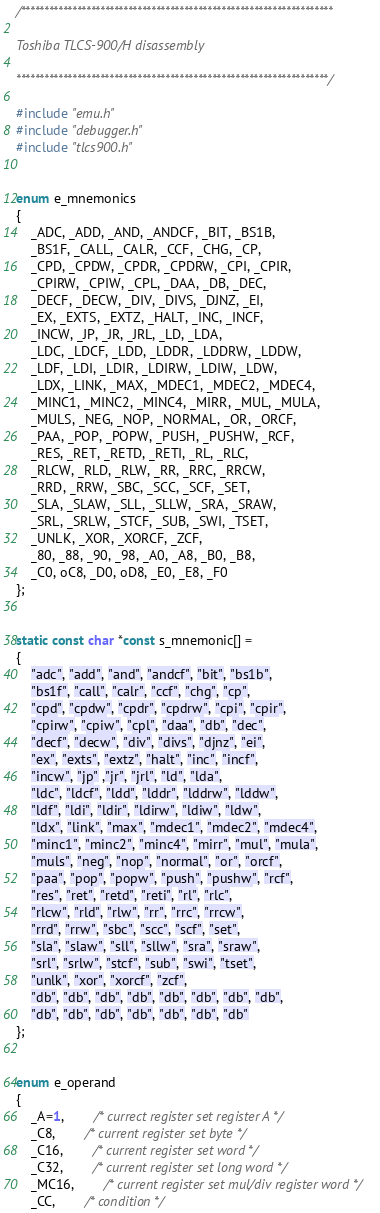<code> <loc_0><loc_0><loc_500><loc_500><_C_>/*******************************************************************

Toshiba TLCS-900/H disassembly

*******************************************************************/

#include "emu.h"
#include "debugger.h"
#include "tlcs900.h"


enum e_mnemonics
{
	_ADC, _ADD, _AND, _ANDCF, _BIT, _BS1B,
	_BS1F, _CALL, _CALR, _CCF, _CHG, _CP,
	_CPD, _CPDW, _CPDR, _CPDRW, _CPI, _CPIR,
	_CPIRW, _CPIW, _CPL, _DAA, _DB, _DEC,
	_DECF, _DECW, _DIV, _DIVS, _DJNZ, _EI,
	_EX, _EXTS, _EXTZ, _HALT, _INC, _INCF,
	_INCW, _JP, _JR, _JRL, _LD, _LDA,
	_LDC, _LDCF, _LDD, _LDDR, _LDDRW, _LDDW,
	_LDF, _LDI, _LDIR, _LDIRW, _LDIW, _LDW,
	_LDX, _LINK, _MAX, _MDEC1, _MDEC2, _MDEC4,
	_MINC1, _MINC2, _MINC4, _MIRR, _MUL, _MULA,
	_MULS, _NEG, _NOP, _NORMAL, _OR, _ORCF,
	_PAA, _POP, _POPW, _PUSH, _PUSHW, _RCF,
	_RES, _RET, _RETD, _RETI, _RL, _RLC,
	_RLCW, _RLD, _RLW, _RR, _RRC, _RRCW,
	_RRD, _RRW, _SBC, _SCC, _SCF, _SET,
	_SLA, _SLAW, _SLL, _SLLW, _SRA, _SRAW,
	_SRL, _SRLW, _STCF, _SUB, _SWI, _TSET,
	_UNLK, _XOR, _XORCF, _ZCF,
	_80, _88, _90, _98, _A0, _A8, _B0, _B8,
	_C0, oC8, _D0, oD8, _E0, _E8, _F0
};


static const char *const s_mnemonic[] =
{
	"adc", "add", "and", "andcf", "bit", "bs1b",
	"bs1f", "call", "calr", "ccf", "chg", "cp",
	"cpd", "cpdw", "cpdr", "cpdrw", "cpi", "cpir",
	"cpirw", "cpiw", "cpl", "daa", "db", "dec",
	"decf", "decw", "div", "divs", "djnz", "ei",
	"ex", "exts", "extz", "halt", "inc", "incf",
	"incw", "jp" ,"jr", "jrl", "ld", "lda",
	"ldc", "ldcf", "ldd", "lddr", "lddrw", "lddw",
	"ldf", "ldi", "ldir", "ldirw", "ldiw", "ldw",
	"ldx", "link", "max", "mdec1", "mdec2", "mdec4",
	"minc1", "minc2", "minc4", "mirr", "mul", "mula",
	"muls", "neg", "nop", "normal", "or", "orcf",
	"paa", "pop", "popw", "push", "pushw", "rcf",
	"res", "ret", "retd", "reti", "rl", "rlc",
	"rlcw", "rld", "rlw", "rr", "rrc", "rrcw",
	"rrd", "rrw", "sbc", "scc", "scf", "set",
	"sla", "slaw", "sll", "sllw", "sra", "sraw",
	"srl", "srlw", "stcf", "sub", "swi", "tset",
	"unlk", "xor", "xorcf", "zcf",
	"db", "db", "db", "db", "db", "db", "db", "db",
	"db", "db", "db", "db", "db", "db", "db"
};


enum e_operand
{
	_A=1,		/* currect register set register A */
	_C8,		/* current register set byte */
	_C16,		/* current register set word */
	_C32,		/* current register set long word */
	_MC16,		/* current register set mul/div register word */
	_CC,		/* condition */</code> 